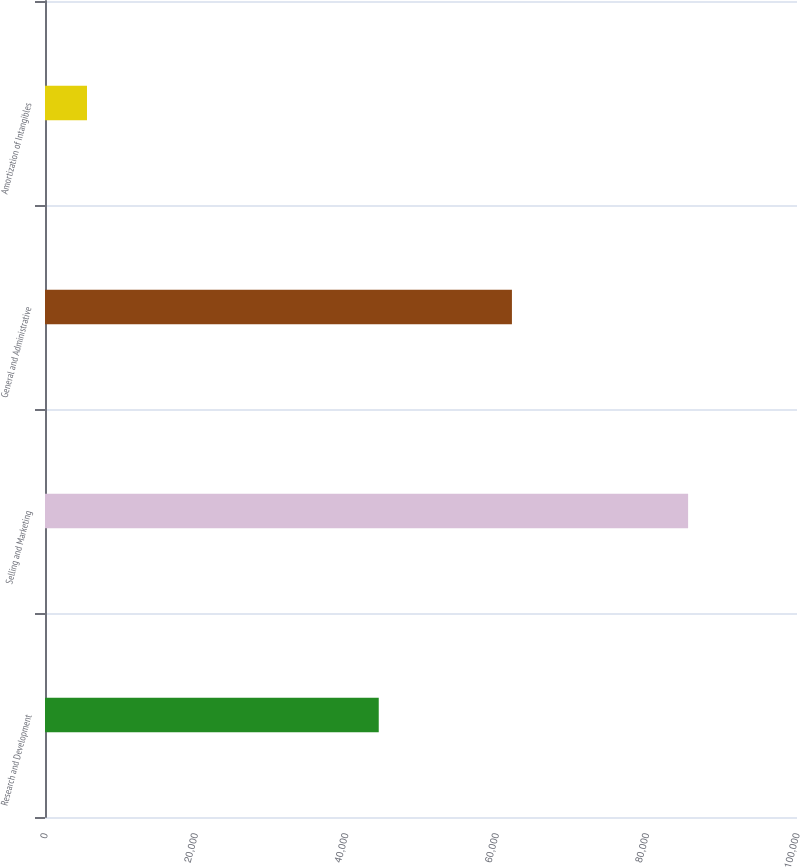<chart> <loc_0><loc_0><loc_500><loc_500><bar_chart><fcel>Research and Development<fcel>Selling and Marketing<fcel>General and Administrative<fcel>Amortization of Intangibles<nl><fcel>44381<fcel>85520<fcel>62092<fcel>5584<nl></chart> 